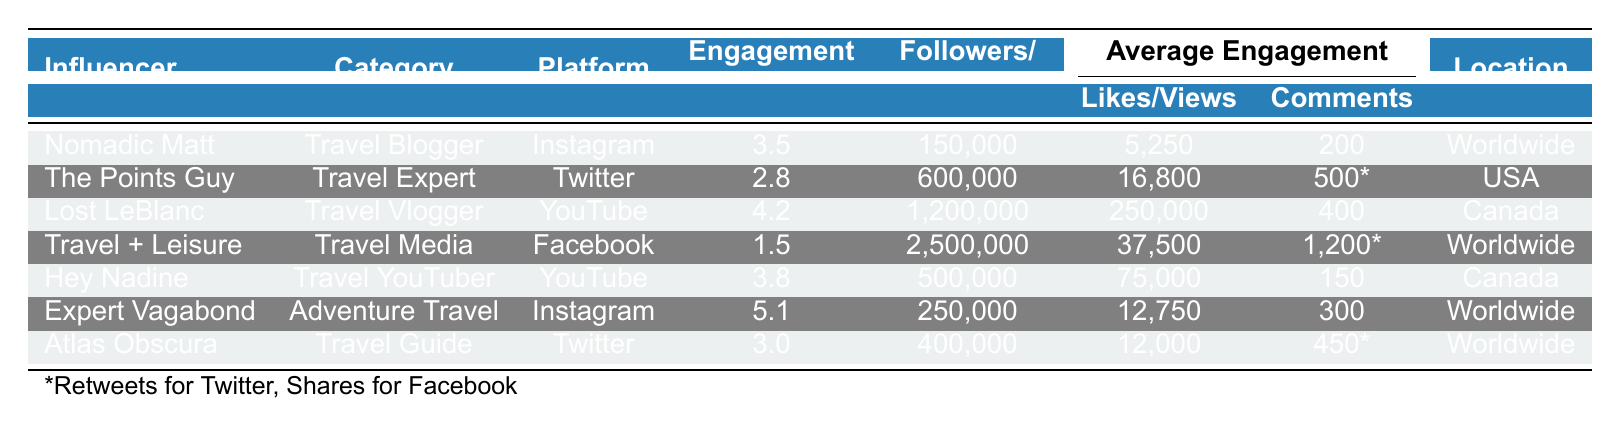What is the engagement rate for Expert Vagabond? The table lists the engagement rates for each influencer, and Expert Vagabond's engagement rate is noted as 5.1%.
Answer: 5.1% Which influencer has the highest number of followers/subscribers? By comparing the follower and subscriber counts listed, Travel + Leisure has the highest count with 2,500,000 followers.
Answer: 2,500,000 How many average likes does Lost LeBlanc receive per video? The average likes for Lost LeBlanc as indicated in the table are 250,000.
Answer: 250,000 Is the engagement rate for Hey Nadine higher than that for The Points Guy? Hey Nadine has an engagement rate of 3.8%, while The Points Guy has an engagement rate of 2.8%. Since 3.8% is greater than 2.8%, the statement is true.
Answer: Yes What is the average engagement rate of all influencers listed in the table? To find the average engagement rate, sum the engagement rates (3.5 + 2.8 + 4.2 + 1.5 + 3.8 + 5.1 + 3.0) = 24.9, then divide by the number of influencers, which is 7. So, 24.9 / 7 = approximately 3.56%.
Answer: 3.56% Which platform has the lowest engagement rate among the influencers? The table shows engagement rates for all influencers, and Travel + Leisure on Facebook has the lowest engagement rate at 1.5%.
Answer: 1.5% How many more average comments does The Points Guy receive compared to Nomadic Matt? The average comments for The Points Guy are 500, while for Nomadic Matt, it's 200. The difference is 500 - 200 = 300 comments.
Answer: 300 Are there any influencers located in Canada? Both Lost LeBlanc and Hey Nadine are listed with Canada as their location, confirming the existence of influencers from Canada.
Answer: Yes Which influencer has the highest average likes? The table indicates that Travel + Leisure has the highest average likes at 37,500.
Answer: 37,500 What is the location of Atlas Obscura? The table states that Atlas Obscura is located in Worldwide.
Answer: Worldwide If Expert Vagabond and Nomadic Matt combined their followers, how many would they have? Expert Vagabond has 250,000 followers and Nomadic Matt has 150,000 followers. Combining them gives 250,000 + 150,000 = 400,000 followers.
Answer: 400,000 